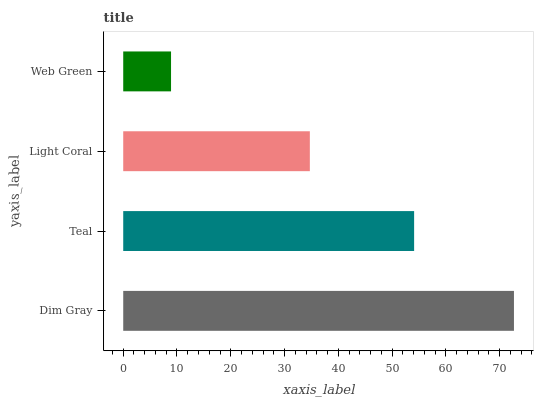Is Web Green the minimum?
Answer yes or no. Yes. Is Dim Gray the maximum?
Answer yes or no. Yes. Is Teal the minimum?
Answer yes or no. No. Is Teal the maximum?
Answer yes or no. No. Is Dim Gray greater than Teal?
Answer yes or no. Yes. Is Teal less than Dim Gray?
Answer yes or no. Yes. Is Teal greater than Dim Gray?
Answer yes or no. No. Is Dim Gray less than Teal?
Answer yes or no. No. Is Teal the high median?
Answer yes or no. Yes. Is Light Coral the low median?
Answer yes or no. Yes. Is Dim Gray the high median?
Answer yes or no. No. Is Teal the low median?
Answer yes or no. No. 